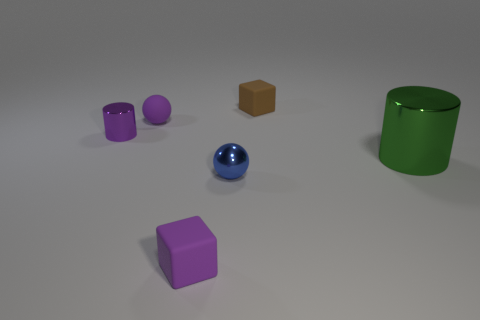There is a block behind the purple rubber object in front of the tiny shiny cylinder; what number of tiny purple objects are in front of it?
Provide a short and direct response. 3. What number of cylinders are both to the left of the blue ball and right of the small matte ball?
Provide a short and direct response. 0. The small metallic object that is the same color as the small matte sphere is what shape?
Your response must be concise. Cylinder. Is the green cylinder made of the same material as the tiny blue sphere?
Provide a succinct answer. Yes. What is the shape of the matte thing right of the cube that is in front of the cylinder that is on the left side of the small brown block?
Your answer should be compact. Cube. Are there fewer blue shiny spheres on the left side of the tiny blue metallic object than purple spheres on the right side of the large green cylinder?
Keep it short and to the point. No. What shape is the metal thing to the left of the blue shiny ball that is in front of the small matte ball?
Ensure brevity in your answer.  Cylinder. Is there any other thing that is the same color as the large shiny object?
Ensure brevity in your answer.  No. Does the tiny cylinder have the same color as the tiny matte sphere?
Offer a terse response. Yes. What number of purple things are large metal cylinders or small rubber spheres?
Your response must be concise. 1. 